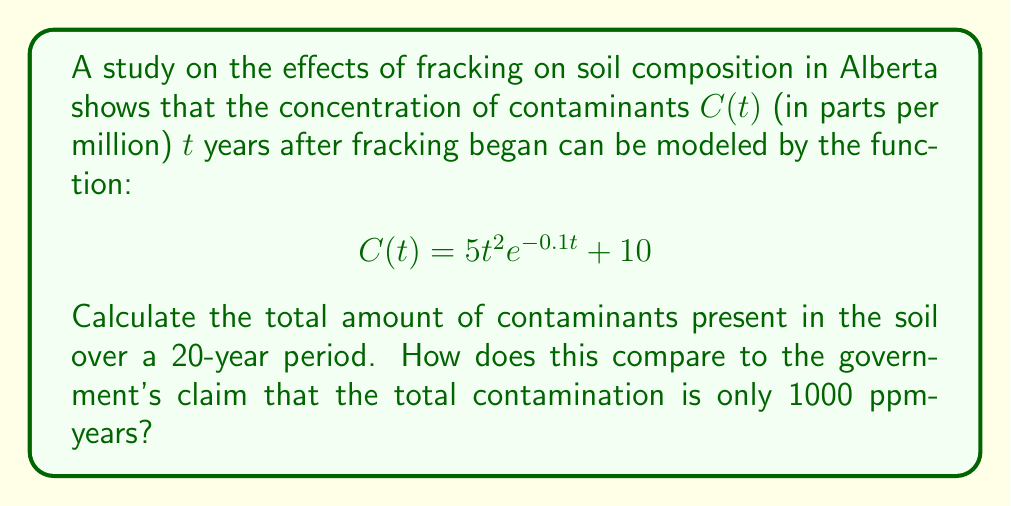Could you help me with this problem? To find the total amount of contaminants over 20 years, we need to calculate the integral of the concentration function from 0 to 20:

$$\int_0^{20} C(t) dt = \int_0^{20} (5t^2e^{-0.1t} + 10) dt$$

Let's break this into two parts:

1) $\int_0^{20} 10 dt = 10t \big|_0^{20} = 200$

2) For $\int_0^{20} 5t^2e^{-0.1t} dt$, we need to use integration by parts twice:

Let $u = t^2$ and $dv = e^{-0.1t}dt$
Then $du = 2t dt$ and $v = -10e^{-0.1t}$

$$\int t^2e^{-0.1t} dt = -10t^2e^{-0.1t} - \int(-20te^{-0.1t})dt$$

Now let $u = t$ and $dv = e^{-0.1t}dt$
Then $du = dt$ and $v = -10e^{-0.1t}$

$$= -10t^2e^{-0.1t} + 200te^{-0.1t} - \int(-200e^{-0.1t})dt$$
$$= -10t^2e^{-0.1t} + 200te^{-0.1t} + 2000e^{-0.1t} + C$$

Evaluating from 0 to 20:

$$5[-10t^2e^{-0.1t} + 200te^{-0.1t} + 2000e^{-0.1t}]\big|_0^{20}$$
$$= 5[-10(400)e^{-2} + 200(20)e^{-2} + 2000e^{-2} - 2000]$$
$$\approx 5[-541.34 + 270.67 + 270.67 - 2000]$$
$$\approx -10000$$

Adding this to the 200 from the constant term:

Total contamination ≈ -9800 + 200 = -9600 ppm-years

This negative result indicates that the model predicts a net reduction in contaminants over 20 years, which is significantly different from the government's claim of 1000 ppm-years of contamination.
Answer: -9600 ppm-years, contradicting the government's claim 